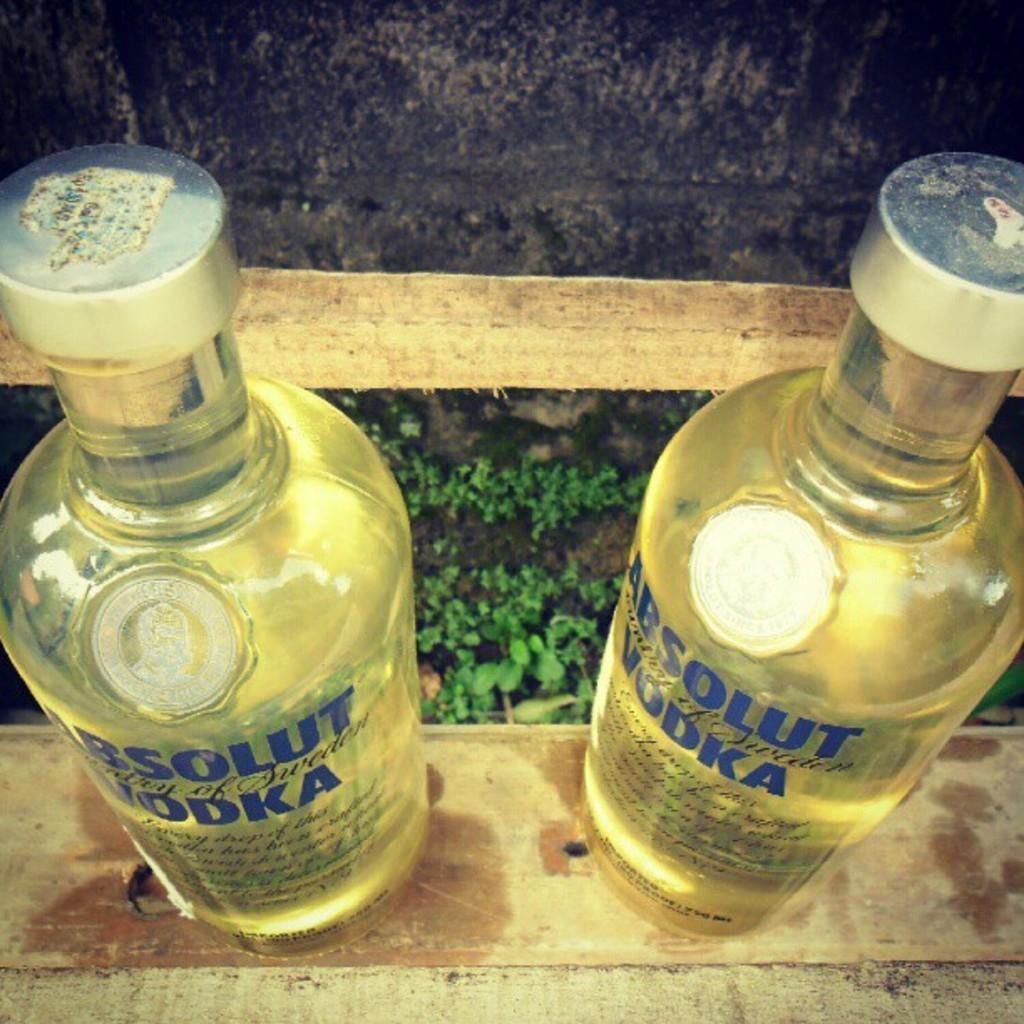How would you summarize this image in a sentence or two? In this image there are two bottles. At the bottom there are plants. 